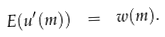<formula> <loc_0><loc_0><loc_500><loc_500>E ( u ^ { \prime } ( m ) ) \ = \ w ( m ) .</formula> 